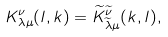<formula> <loc_0><loc_0><loc_500><loc_500>K _ { \lambda \mu } ^ { \nu } ( l , k ) = \widetilde { K } _ { \widetilde { \lambda } \mu } ^ { \widetilde { \nu } } ( k , l ) ,</formula> 